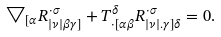Convert formula to latex. <formula><loc_0><loc_0><loc_500><loc_500>\bigtriangledown _ { [ \alpha } R _ { | \nu | \beta \gamma ] } ^ { \cdot \sigma } + T _ { \cdot [ \alpha \beta } ^ { \delta } R _ { | \nu | . \gamma ] \delta } ^ { \cdot \sigma } = 0 .</formula> 